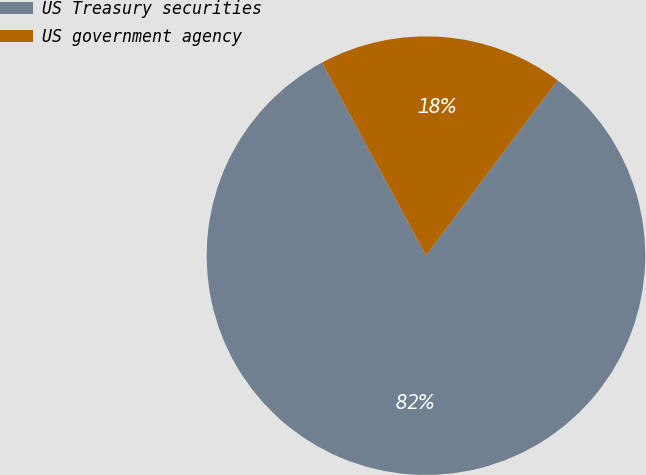Convert chart to OTSL. <chart><loc_0><loc_0><loc_500><loc_500><pie_chart><fcel>US Treasury securities<fcel>US government agency<nl><fcel>81.88%<fcel>18.12%<nl></chart> 